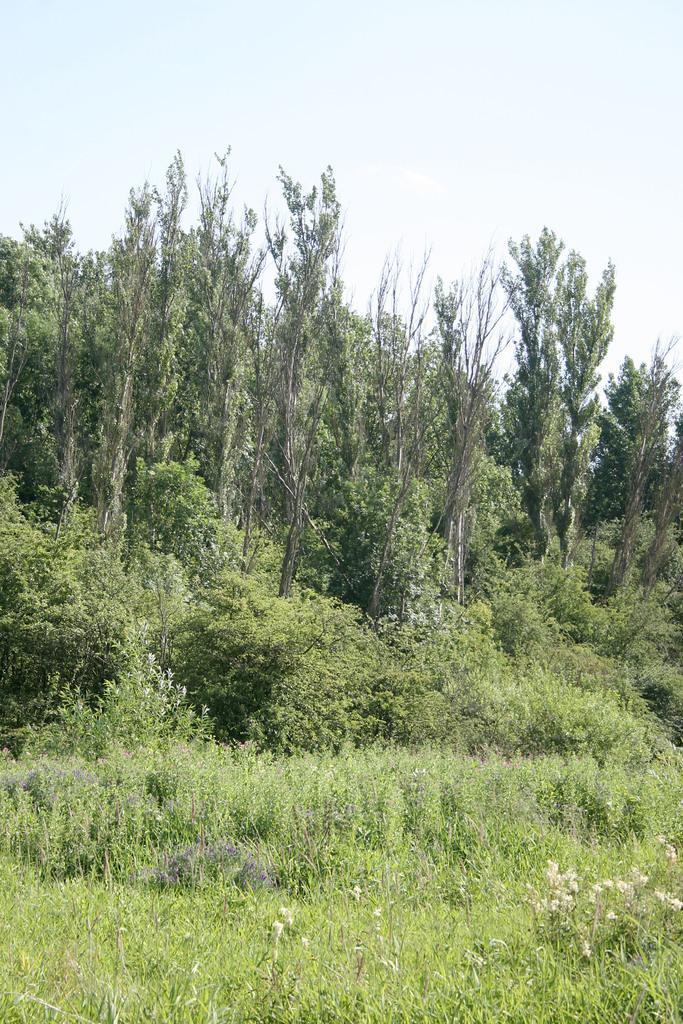How would you summarize this image in a sentence or two? In this image there are small plants and some grass in the bottom of this image and there are some trees in the background. There is a sky on the top of this image. 